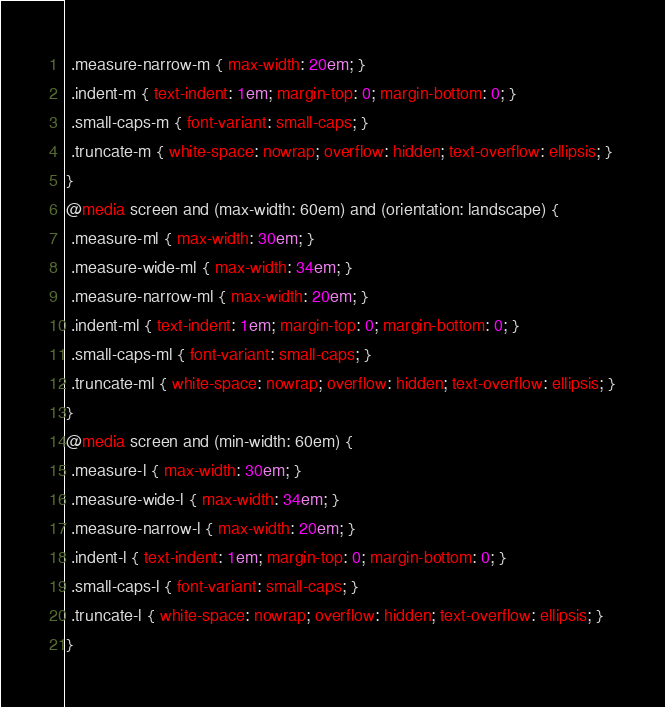<code> <loc_0><loc_0><loc_500><loc_500><_CSS_> .measure-narrow-m { max-width: 20em; }
 .indent-m { text-indent: 1em; margin-top: 0; margin-bottom: 0; }
 .small-caps-m { font-variant: small-caps; }
 .truncate-m { white-space: nowrap; overflow: hidden; text-overflow: ellipsis; }
}
@media screen and (max-width: 60em) and (orientation: landscape) {
 .measure-ml { max-width: 30em; }
 .measure-wide-ml { max-width: 34em; }
 .measure-narrow-ml { max-width: 20em; }
 .indent-ml { text-indent: 1em; margin-top: 0; margin-bottom: 0; }
 .small-caps-ml { font-variant: small-caps; }
 .truncate-ml { white-space: nowrap; overflow: hidden; text-overflow: ellipsis; }
}
@media screen and (min-width: 60em) {
 .measure-l { max-width: 30em; }
 .measure-wide-l { max-width: 34em; }
 .measure-narrow-l { max-width: 20em; }
 .indent-l { text-indent: 1em; margin-top: 0; margin-bottom: 0; }
 .small-caps-l { font-variant: small-caps; }
 .truncate-l { white-space: nowrap; overflow: hidden; text-overflow: ellipsis; }
}

</code> 